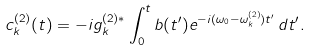Convert formula to latex. <formula><loc_0><loc_0><loc_500><loc_500>c _ { k } ^ { ( 2 ) } ( t ) = - i g _ { k } ^ { ( 2 ) \ast } \int _ { 0 } ^ { t } b ( t ^ { \prime } ) e ^ { - i ( \omega _ { 0 } - \omega _ { k } ^ { ( 2 ) } ) t ^ { \prime } } \, d t ^ { \prime } .</formula> 